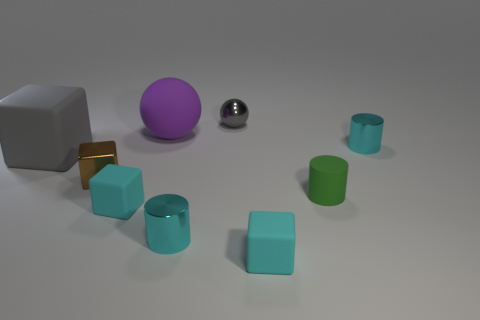Subtract all gray rubber cubes. How many cubes are left? 3 Subtract 1 cubes. How many cubes are left? 3 Subtract all cyan cylinders. How many cylinders are left? 1 Subtract all blue cubes. How many green cylinders are left? 1 Subtract all large gray objects. Subtract all gray cubes. How many objects are left? 7 Add 4 metal cylinders. How many metal cylinders are left? 6 Add 8 yellow matte spheres. How many yellow matte spheres exist? 8 Subtract 0 purple cylinders. How many objects are left? 9 Subtract all cylinders. How many objects are left? 6 Subtract all cyan cylinders. Subtract all yellow balls. How many cylinders are left? 1 